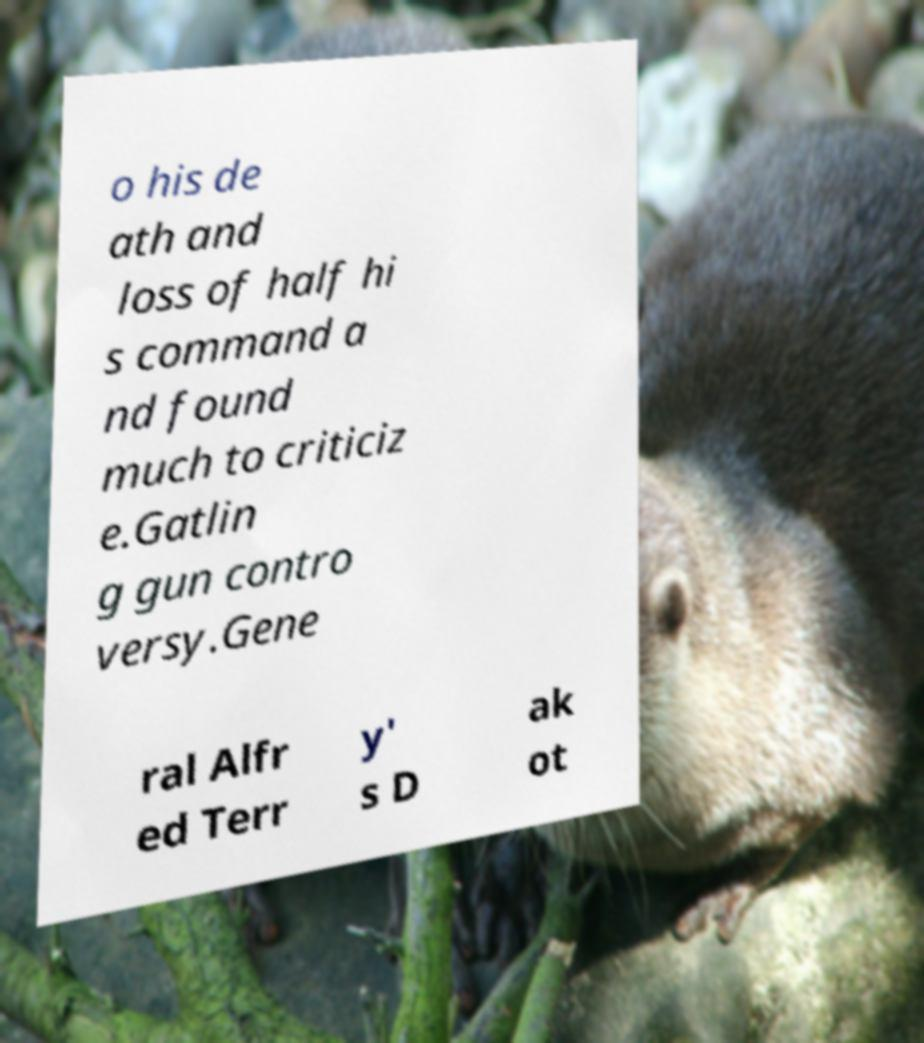Please identify and transcribe the text found in this image. o his de ath and loss of half hi s command a nd found much to criticiz e.Gatlin g gun contro versy.Gene ral Alfr ed Terr y' s D ak ot 